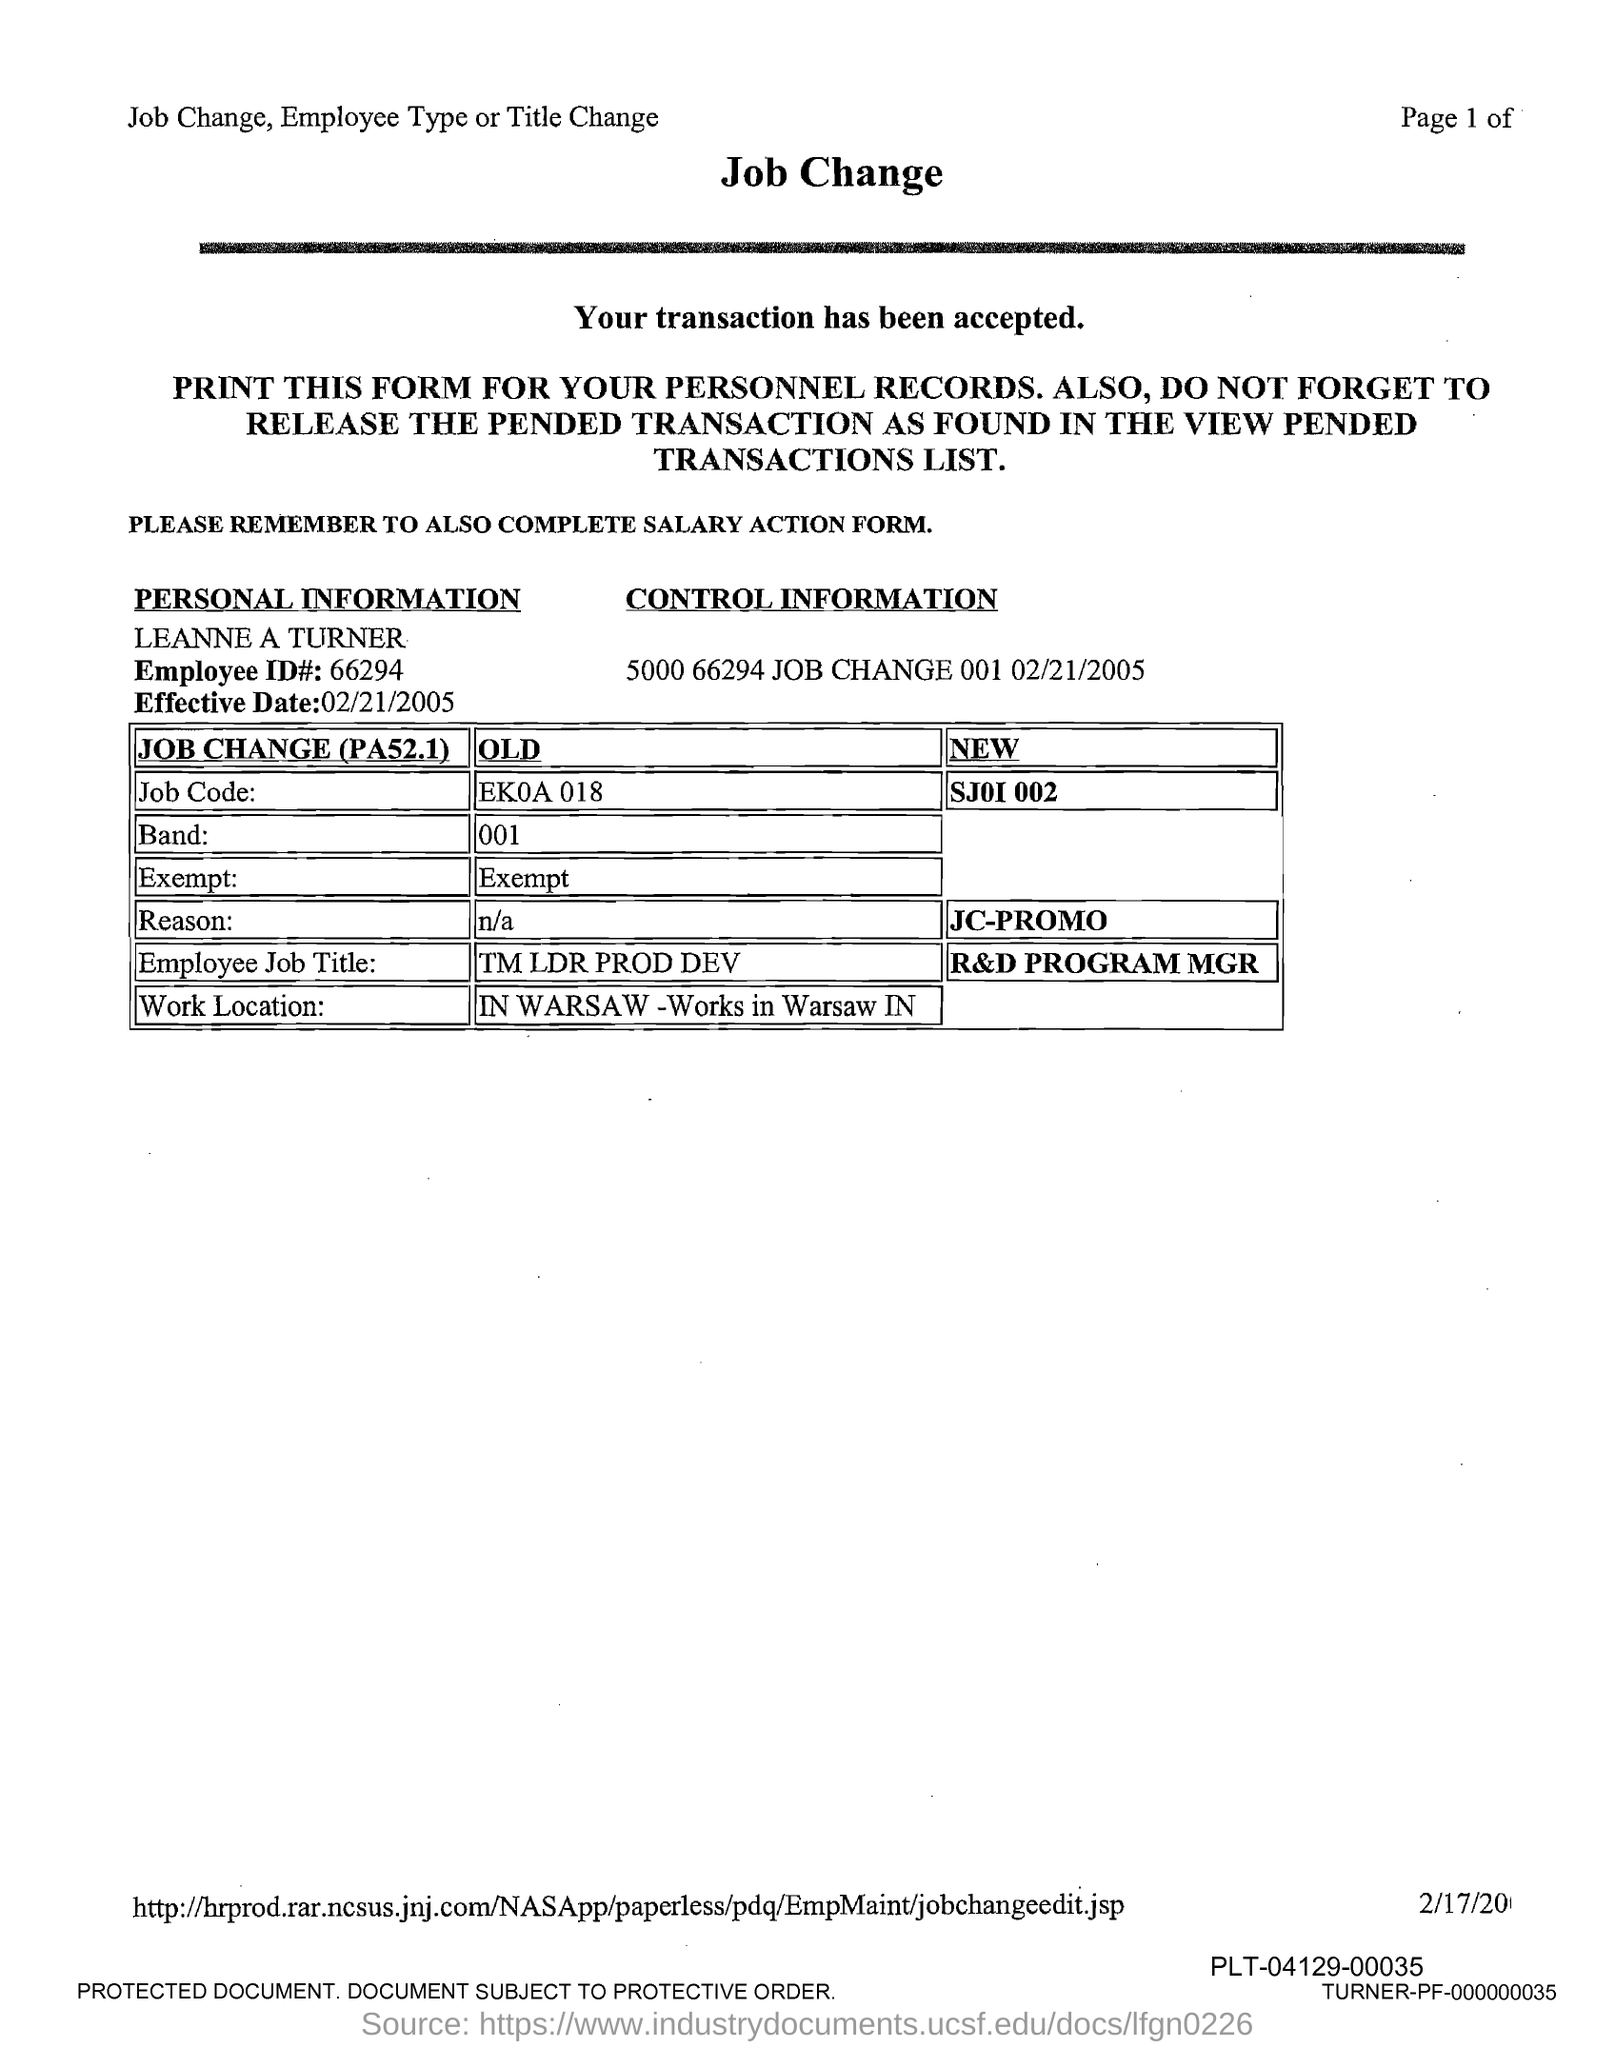What is the Employee ID mentioned in this form?
Keep it short and to the point. 66294. What is the date mentioned in this form?
Your answer should be very brief. 02/21/2005. What is the old job code mentioned in this form?
Make the answer very short. EK0A 018. What is the new job code mentioned in this form?
Keep it short and to the point. SJ01 002. What is the old Employee Job Title mentioned?
Offer a very short reply. Tm ldr prod dev. What is the new Employee Job Title mentioned?
Your answer should be compact. R&D PROGRAM MGR. Where is the work location mentioned in this form
Offer a terse response. IN WARSAW - Works in Warsaw IN. What is the employee named mentioned in this form?
Keep it short and to the point. Leanne a turner. 